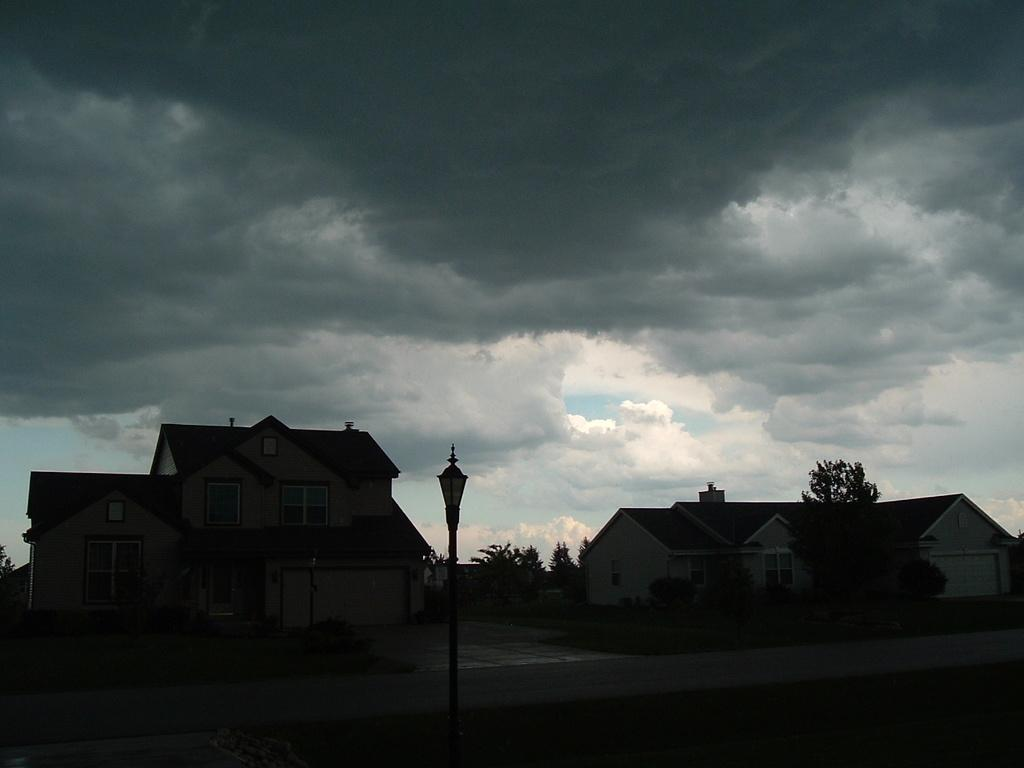What is located at the bottom of the picture? There is a road at the bottom of the picture. What can be found on the road? There is a street light on the road. What is in the middle of the picture? There are trees and buildings in the middle of the picture. What is visible at the top of the picture? The sky is visible at the top of the picture. Where is the manager standing in the image? There is no manager present in the image. What type of pump can be seen in the middle of the picture? There is no pump present in the image; it features a road, street light, trees, buildings, and sky. 